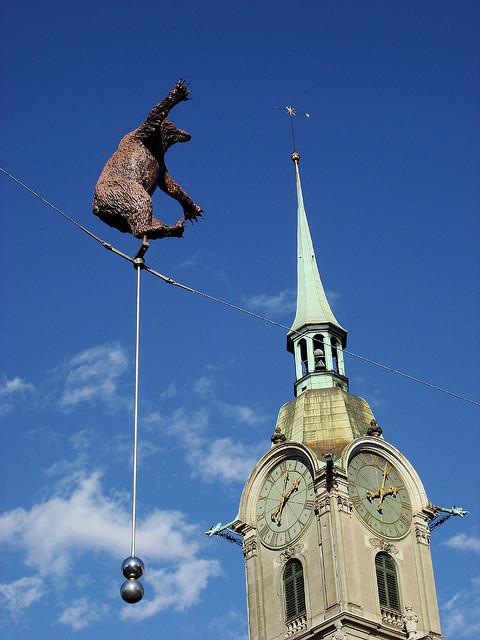In which direction is the bear seen here currently moving?

Choices:
A) down
B) up
C) forward
D) none none 